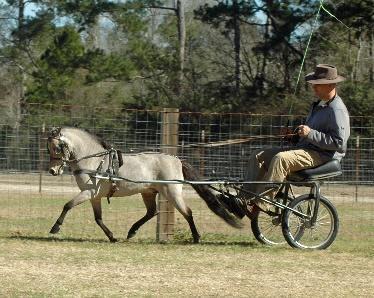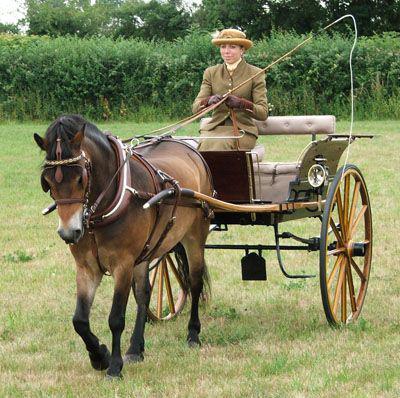The first image is the image on the left, the second image is the image on the right. Assess this claim about the two images: "One cart with two wheels is driven by a man and one by a woman, each holding a whip, to control the single horse.". Correct or not? Answer yes or no. Yes. The first image is the image on the left, the second image is the image on the right. Given the left and right images, does the statement "In one of the images there is one woman riding in a cart pulled by a horse." hold true? Answer yes or no. Yes. 